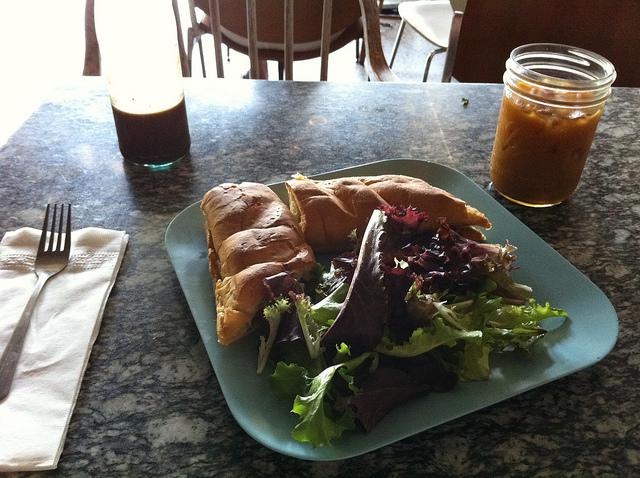Has the meal been eaten?
Short answer required. No. How many tines in the fork?
Quick response, please. 4. How many different kinds of lettuce on the plate?
Answer briefly. 2. 